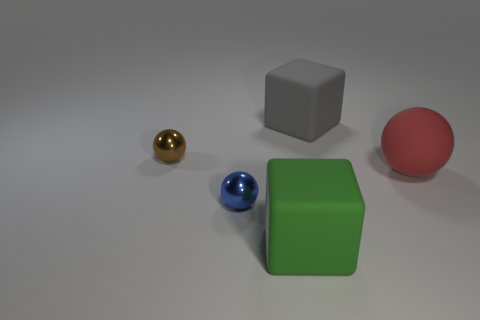There is a small object that is behind the red matte ball; are there any tiny brown shiny spheres that are behind it?
Ensure brevity in your answer.  No. What number of big rubber blocks are right of the large gray block?
Keep it short and to the point. 0. The other big matte object that is the same shape as the big gray thing is what color?
Ensure brevity in your answer.  Green. Does the small object that is in front of the brown thing have the same material as the block behind the small brown metal ball?
Your response must be concise. No. There is a large sphere; is it the same color as the small metal thing in front of the red ball?
Keep it short and to the point. No. What shape is the object that is both on the left side of the big gray matte cube and right of the blue thing?
Make the answer very short. Cube. How many spheres are there?
Give a very brief answer. 3. There is another rubber thing that is the same shape as the green matte object; what size is it?
Offer a terse response. Large. There is a object behind the tiny brown sphere; is its shape the same as the blue thing?
Keep it short and to the point. No. What color is the ball on the right side of the blue metal ball?
Provide a short and direct response. Red. 